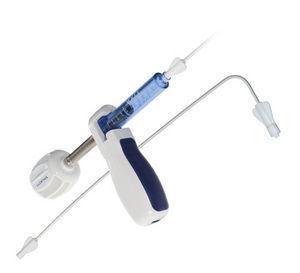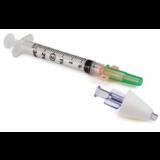The first image is the image on the left, the second image is the image on the right. For the images shown, is this caption "There are two pieces of flexible tubing in the image on the right." true? Answer yes or no. No. 